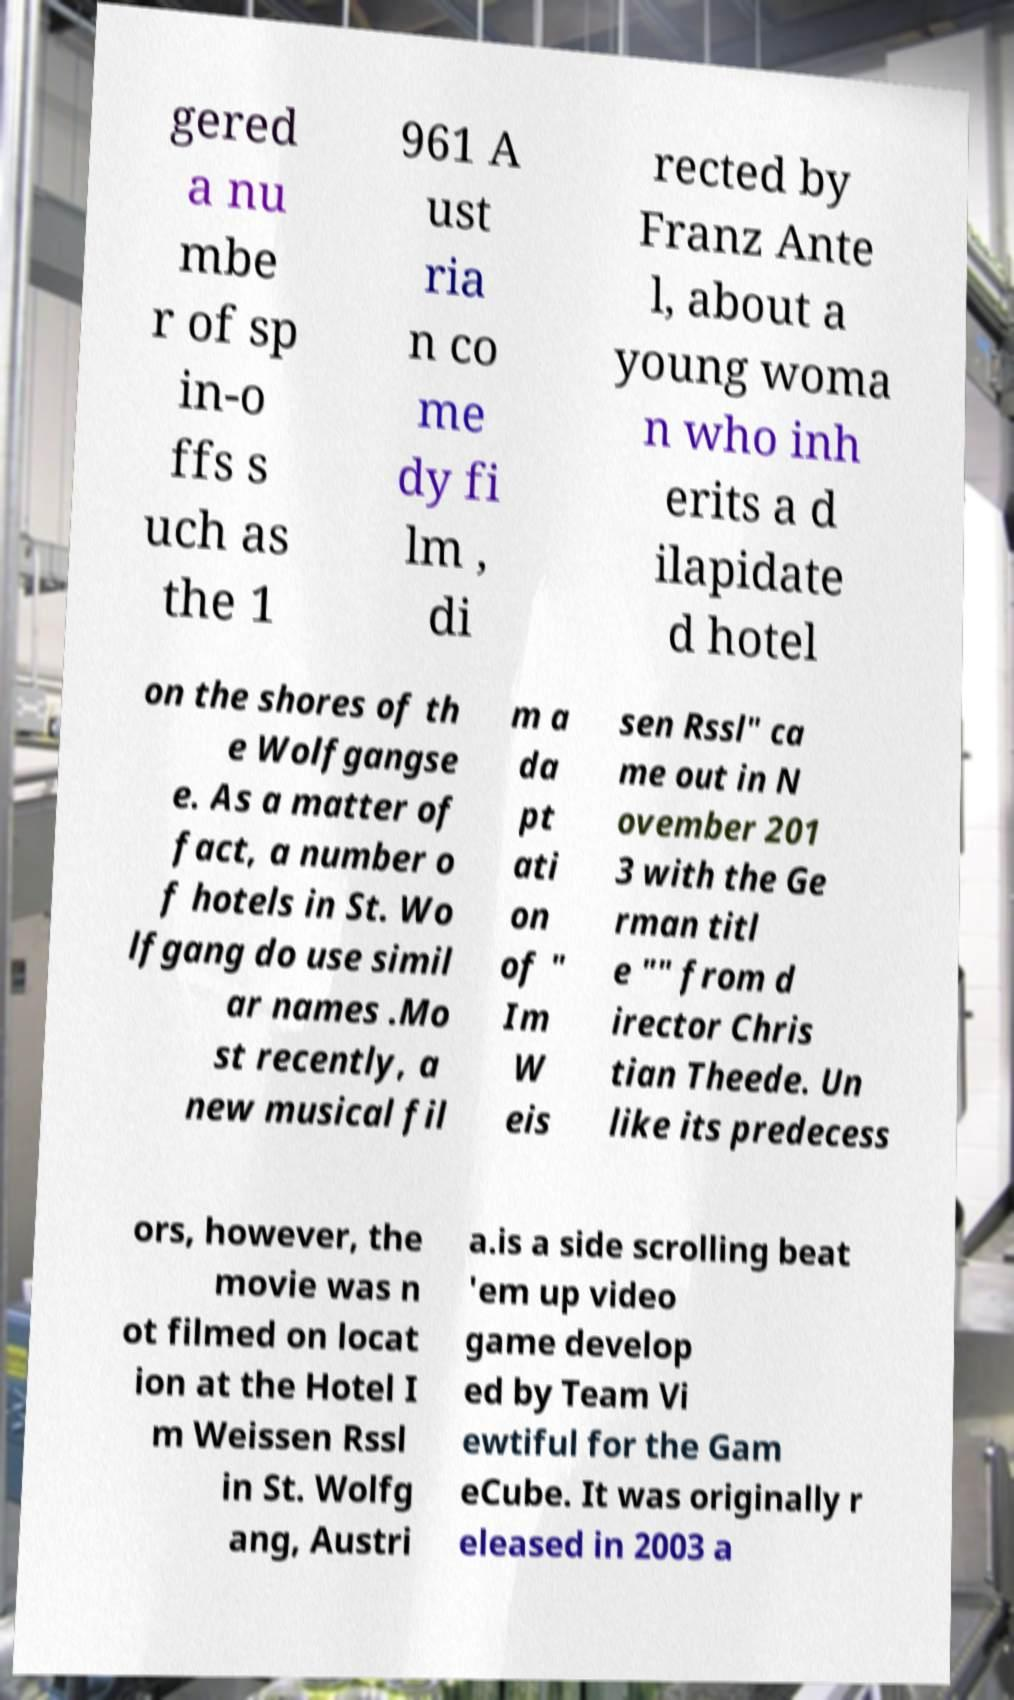There's text embedded in this image that I need extracted. Can you transcribe it verbatim? gered a nu mbe r of sp in-o ffs s uch as the 1 961 A ust ria n co me dy fi lm , di rected by Franz Ante l, about a young woma n who inh erits a d ilapidate d hotel on the shores of th e Wolfgangse e. As a matter of fact, a number o f hotels in St. Wo lfgang do use simil ar names .Mo st recently, a new musical fil m a da pt ati on of " Im W eis sen Rssl" ca me out in N ovember 201 3 with the Ge rman titl e "" from d irector Chris tian Theede. Un like its predecess ors, however, the movie was n ot filmed on locat ion at the Hotel I m Weissen Rssl in St. Wolfg ang, Austri a.is a side scrolling beat 'em up video game develop ed by Team Vi ewtiful for the Gam eCube. It was originally r eleased in 2003 a 